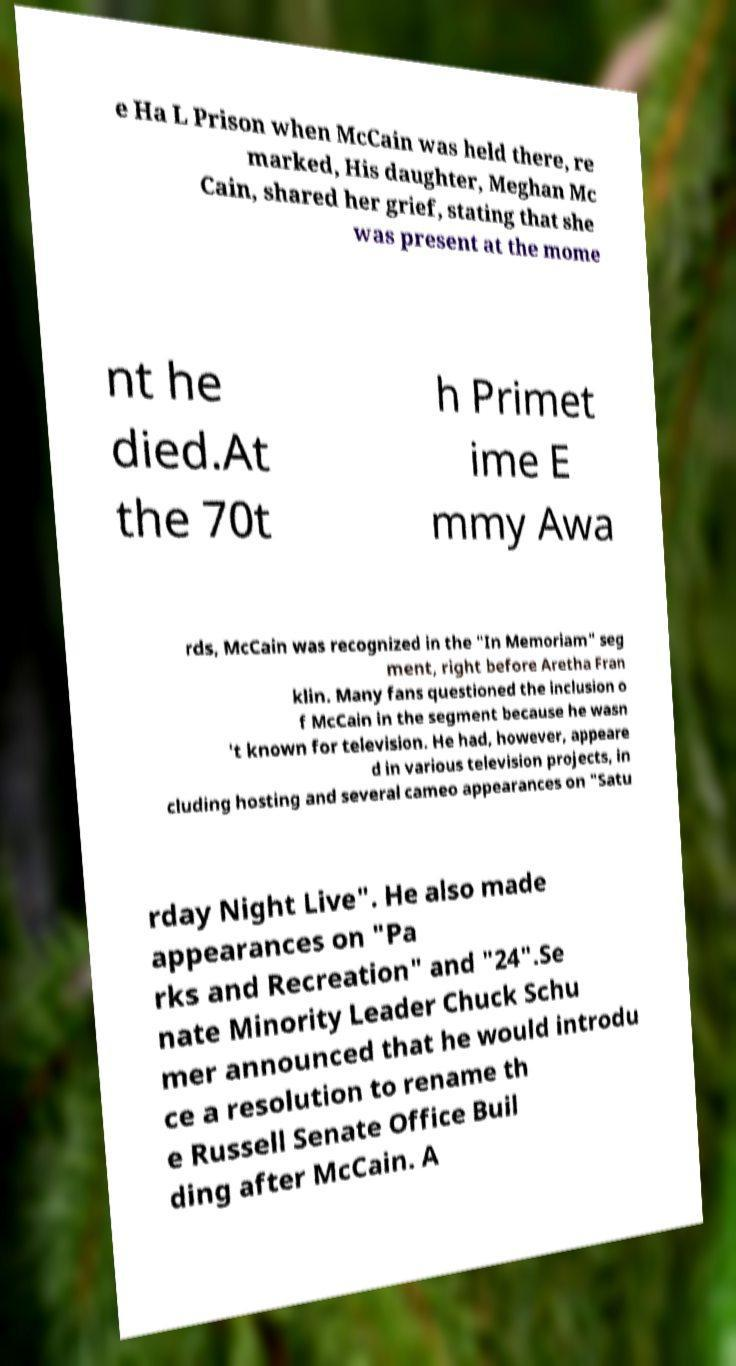I need the written content from this picture converted into text. Can you do that? e Ha L Prison when McCain was held there, re marked, His daughter, Meghan Mc Cain, shared her grief, stating that she was present at the mome nt he died.At the 70t h Primet ime E mmy Awa rds, McCain was recognized in the "In Memoriam" seg ment, right before Aretha Fran klin. Many fans questioned the inclusion o f McCain in the segment because he wasn 't known for television. He had, however, appeare d in various television projects, in cluding hosting and several cameo appearances on "Satu rday Night Live". He also made appearances on "Pa rks and Recreation" and "24".Se nate Minority Leader Chuck Schu mer announced that he would introdu ce a resolution to rename th e Russell Senate Office Buil ding after McCain. A 